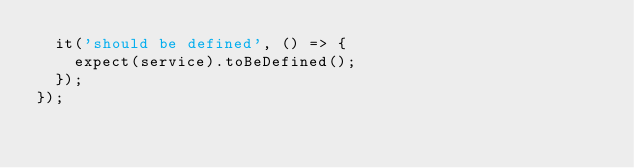<code> <loc_0><loc_0><loc_500><loc_500><_TypeScript_>  it('should be defined', () => {
    expect(service).toBeDefined();
  });
});
</code> 